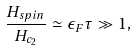Convert formula to latex. <formula><loc_0><loc_0><loc_500><loc_500>\frac { H _ { s p i n } } { H _ { c _ { 2 } } } \simeq \epsilon _ { F } \tau \gg 1 ,</formula> 